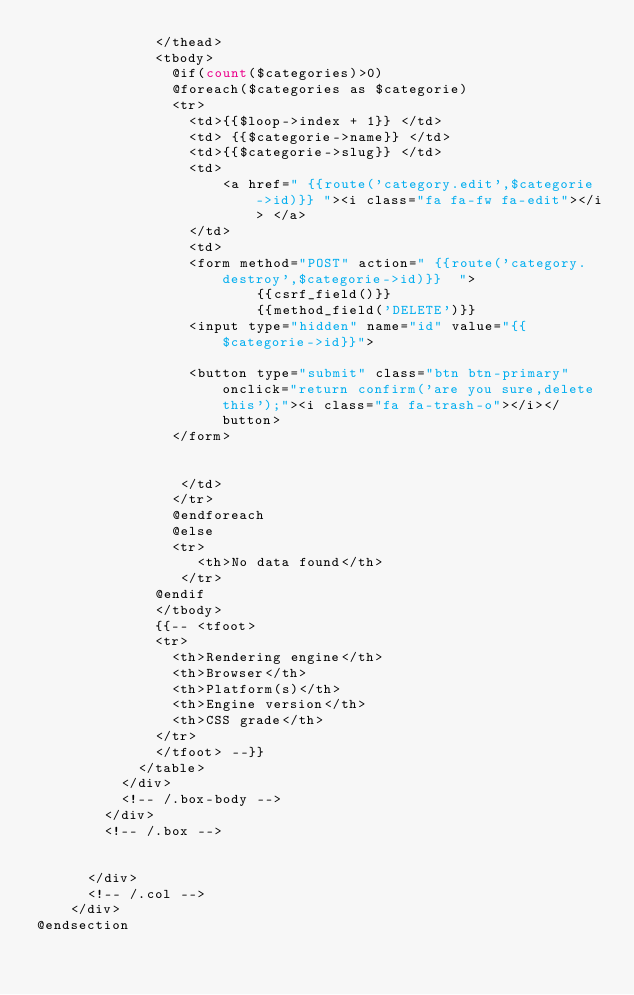Convert code to text. <code><loc_0><loc_0><loc_500><loc_500><_PHP_>              </thead>
              <tbody>
                @if(count($categories)>0)
                @foreach($categories as $categorie)
                <tr>
                  <td>{{$loop->index + 1}} </td>
                  <td> {{$categorie->name}} </td>
                  <td>{{$categorie->slug}} </td>
                  <td>
                      <a href=" {{route('category.edit',$categorie->id)}} "><i class="fa fa-fw fa-edit"></i> </a>
                  </td>
                  <td> 
                  <form method="POST" action=" {{route('category.destroy',$categorie->id)}}  ">
                          {{csrf_field()}}
                          {{method_field('DELETE')}}
                  <input type="hidden" name="id" value="{{$categorie->id}}">
                  
                  <button type="submit" class="btn btn-primary" onclick="return confirm('are you sure,delete this');"><i class="fa fa-trash-o"></i></button>
                </form>
                    
                      
                 </td>
                </tr>
                @endforeach
                @else
                <tr>
                   <th>No data found</th>
                 </tr>
              @endif
              </tbody>
              {{-- <tfoot>
              <tr>
                <th>Rendering engine</th>
                <th>Browser</th>
                <th>Platform(s)</th>
                <th>Engine version</th>
                <th>CSS grade</th>
              </tr>
              </tfoot> --}}
            </table>
          </div>
          <!-- /.box-body -->
        </div>
        <!-- /.box -->

       
      </div>
      <!-- /.col -->
    </div>
@endsection</code> 